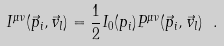Convert formula to latex. <formula><loc_0><loc_0><loc_500><loc_500>I ^ { \mu \nu } ( \vec { p } _ { i } , \vec { v } _ { l } ) = \frac { 1 } { 2 } I _ { 0 } ( p _ { i } ) P ^ { \mu \nu } ( \vec { p } _ { i } , \vec { v } _ { l } ) \ .</formula> 